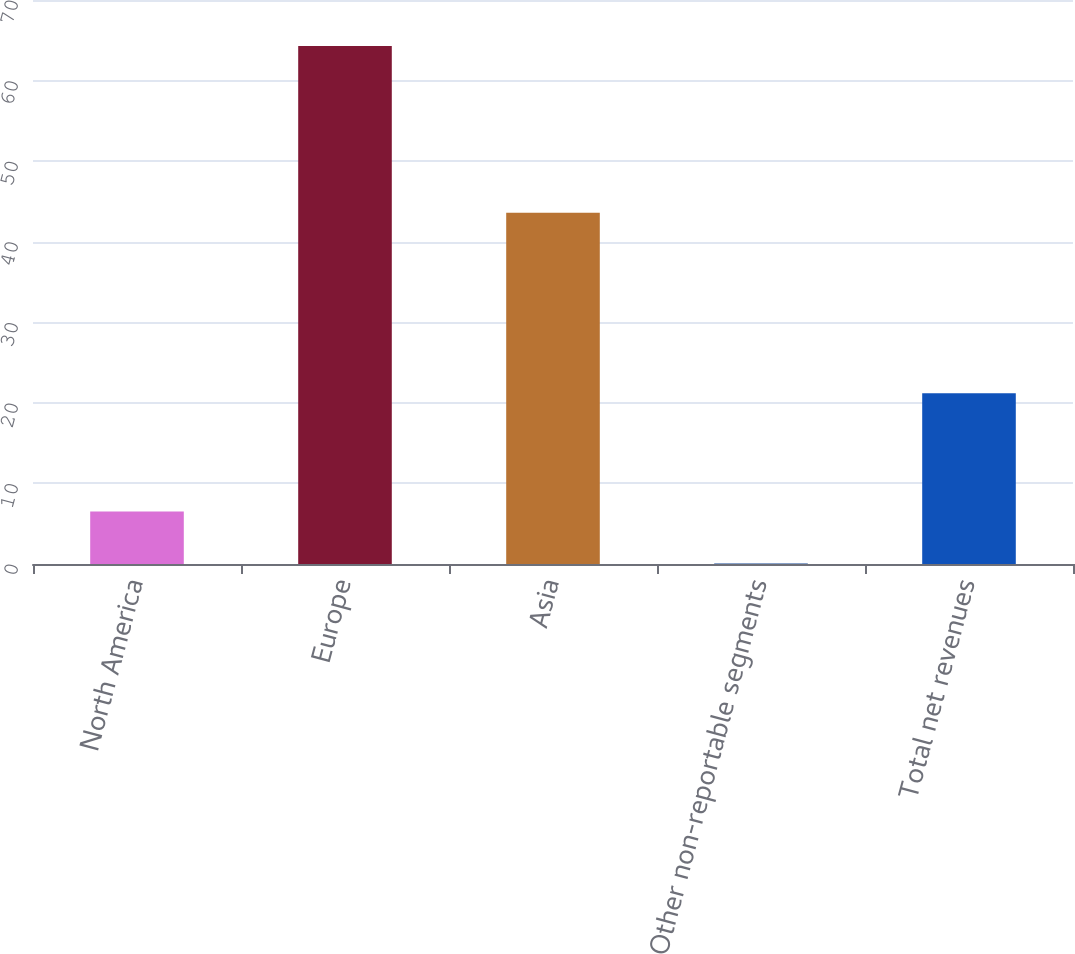Convert chart. <chart><loc_0><loc_0><loc_500><loc_500><bar_chart><fcel>North America<fcel>Europe<fcel>Asia<fcel>Other non-reportable segments<fcel>Total net revenues<nl><fcel>6.52<fcel>64.3<fcel>43.6<fcel>0.1<fcel>21.2<nl></chart> 